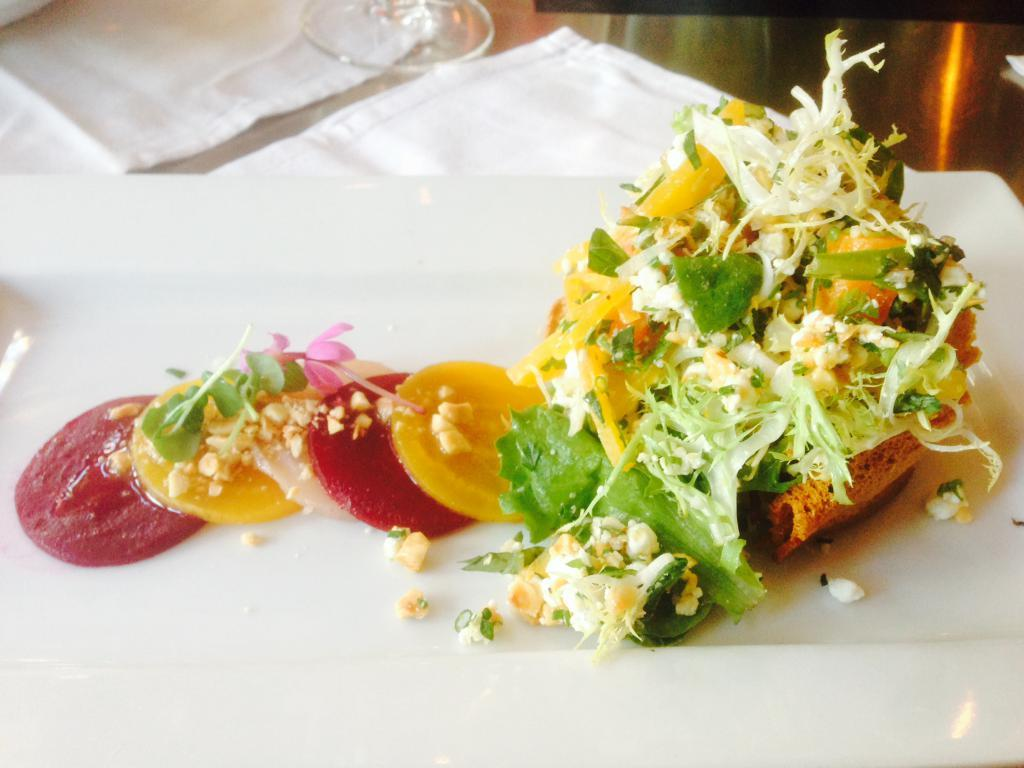What is the main food item visible on the chopping board in the image? The specific food item cannot be determined from the provided facts. What can be seen in the image besides the food item on the chopping board? There is a glass and napkins on the table in the image. What is the acoustic quality of the sound produced by the food item on the chopping board in the image? There is no information about the sound produced by the food item in the image, and therefore no such acoustic quality can be determined. 